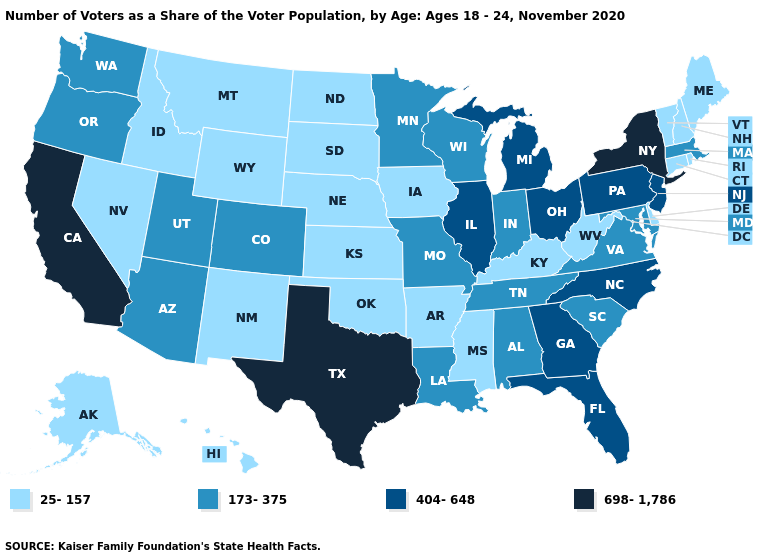Among the states that border Connecticut , which have the lowest value?
Be succinct. Rhode Island. What is the value of Maryland?
Give a very brief answer. 173-375. Name the states that have a value in the range 404-648?
Keep it brief. Florida, Georgia, Illinois, Michigan, New Jersey, North Carolina, Ohio, Pennsylvania. Does Kentucky have a higher value than Iowa?
Quick response, please. No. What is the highest value in the USA?
Be succinct. 698-1,786. What is the lowest value in the Northeast?
Answer briefly. 25-157. Among the states that border Arizona , which have the highest value?
Keep it brief. California. What is the highest value in states that border Oregon?
Short answer required. 698-1,786. What is the value of Vermont?
Keep it brief. 25-157. Name the states that have a value in the range 25-157?
Answer briefly. Alaska, Arkansas, Connecticut, Delaware, Hawaii, Idaho, Iowa, Kansas, Kentucky, Maine, Mississippi, Montana, Nebraska, Nevada, New Hampshire, New Mexico, North Dakota, Oklahoma, Rhode Island, South Dakota, Vermont, West Virginia, Wyoming. Does the map have missing data?
Concise answer only. No. Does Michigan have the highest value in the MidWest?
Quick response, please. Yes. Does Michigan have the same value as Kansas?
Short answer required. No. What is the highest value in the Northeast ?
Concise answer only. 698-1,786. What is the highest value in states that border Pennsylvania?
Concise answer only. 698-1,786. 